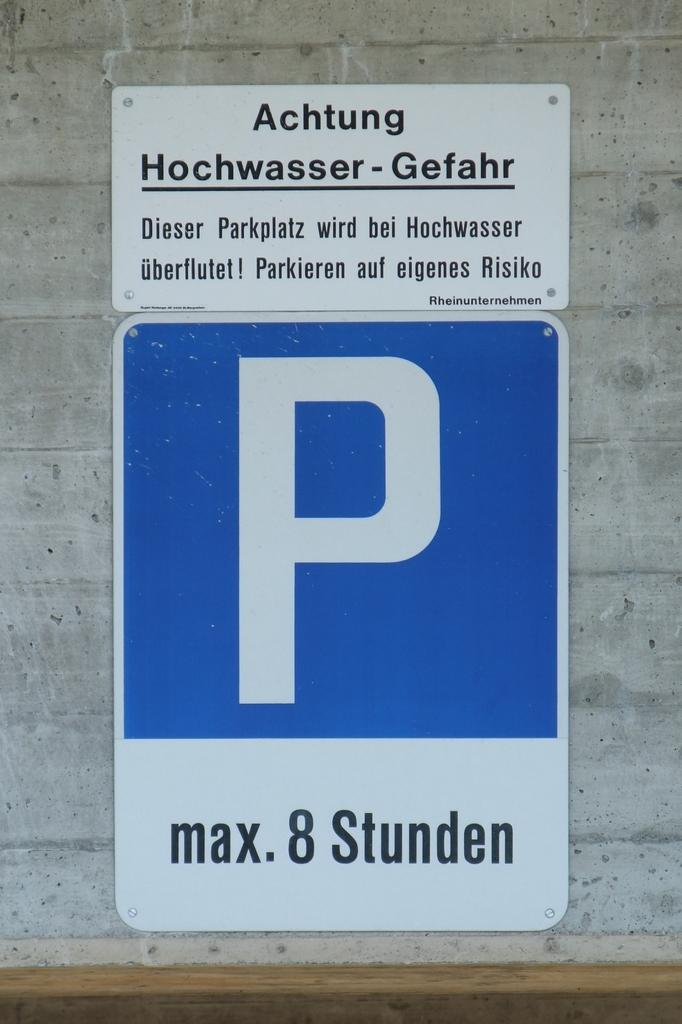<image>
Summarize the visual content of the image. Sign on a wall that has a large P on it and says Max 8 studen. 